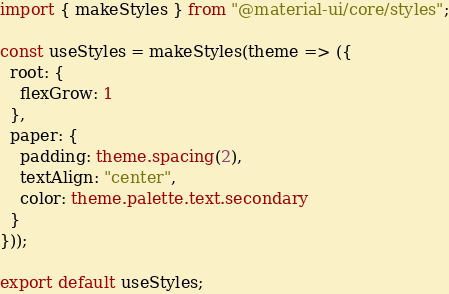Convert code to text. <code><loc_0><loc_0><loc_500><loc_500><_TypeScript_>import { makeStyles } from "@material-ui/core/styles";

const useStyles = makeStyles(theme => ({
  root: {
    flexGrow: 1
  },
  paper: {
    padding: theme.spacing(2),
    textAlign: "center",
    color: theme.palette.text.secondary
  }
}));

export default useStyles;
</code> 